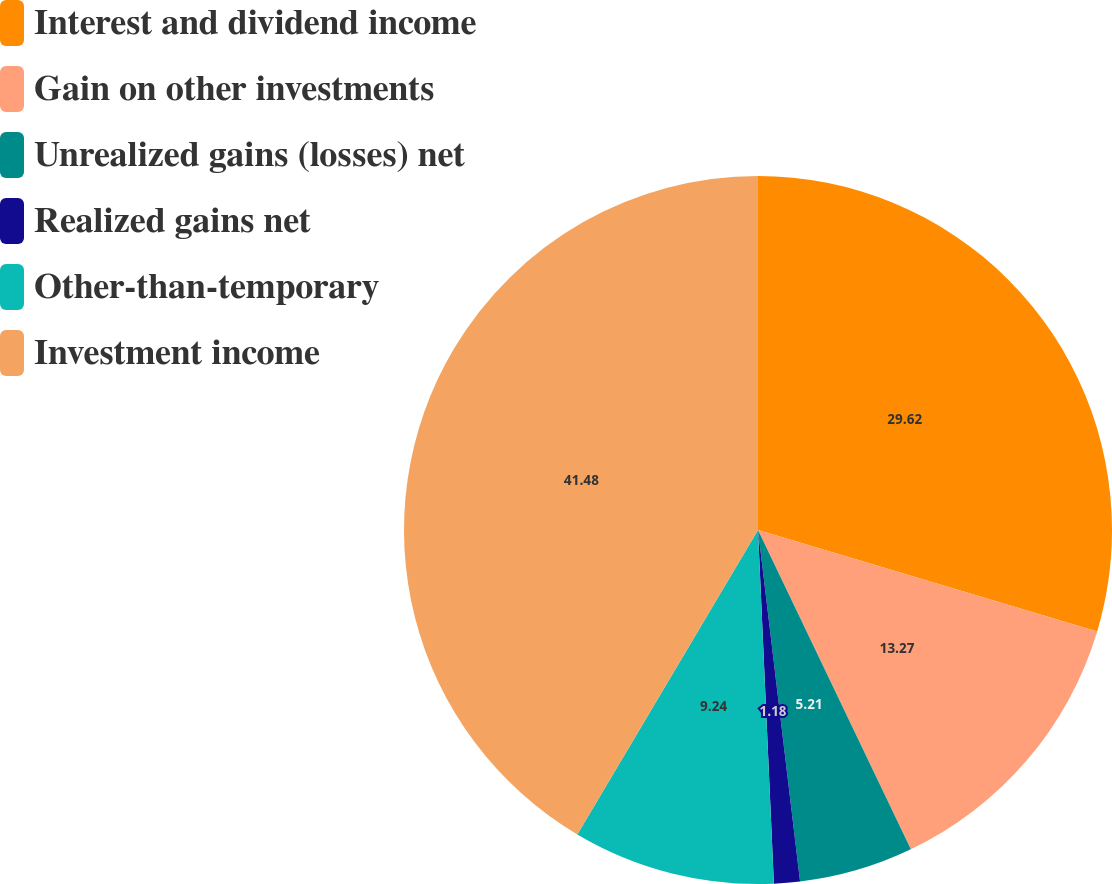<chart> <loc_0><loc_0><loc_500><loc_500><pie_chart><fcel>Interest and dividend income<fcel>Gain on other investments<fcel>Unrealized gains (losses) net<fcel>Realized gains net<fcel>Other-than-temporary<fcel>Investment income<nl><fcel>29.62%<fcel>13.27%<fcel>5.21%<fcel>1.18%<fcel>9.24%<fcel>41.47%<nl></chart> 